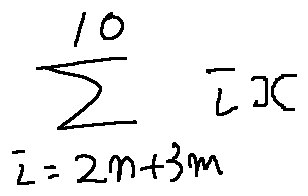Convert formula to latex. <formula><loc_0><loc_0><loc_500><loc_500>\sum \lim i t s _ { i = 2 n + 3 m } ^ { 1 0 } i x</formula> 